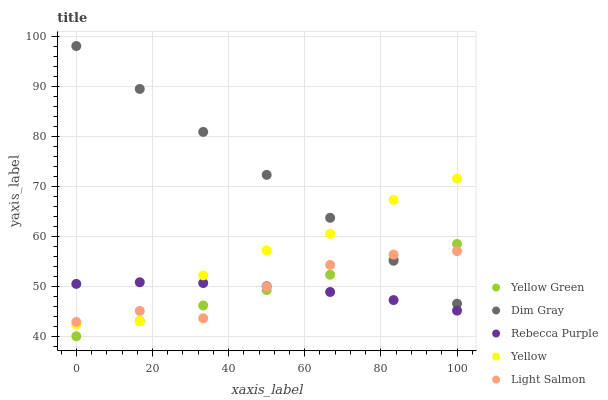Does Rebecca Purple have the minimum area under the curve?
Answer yes or no. Yes. Does Dim Gray have the maximum area under the curve?
Answer yes or no. Yes. Does Yellow Green have the minimum area under the curve?
Answer yes or no. No. Does Yellow Green have the maximum area under the curve?
Answer yes or no. No. Is Yellow Green the smoothest?
Answer yes or no. Yes. Is Yellow the roughest?
Answer yes or no. Yes. Is Dim Gray the smoothest?
Answer yes or no. No. Is Dim Gray the roughest?
Answer yes or no. No. Does Yellow Green have the lowest value?
Answer yes or no. Yes. Does Dim Gray have the lowest value?
Answer yes or no. No. Does Dim Gray have the highest value?
Answer yes or no. Yes. Does Yellow Green have the highest value?
Answer yes or no. No. Is Rebecca Purple less than Dim Gray?
Answer yes or no. Yes. Is Dim Gray greater than Rebecca Purple?
Answer yes or no. Yes. Does Dim Gray intersect Yellow Green?
Answer yes or no. Yes. Is Dim Gray less than Yellow Green?
Answer yes or no. No. Is Dim Gray greater than Yellow Green?
Answer yes or no. No. Does Rebecca Purple intersect Dim Gray?
Answer yes or no. No. 